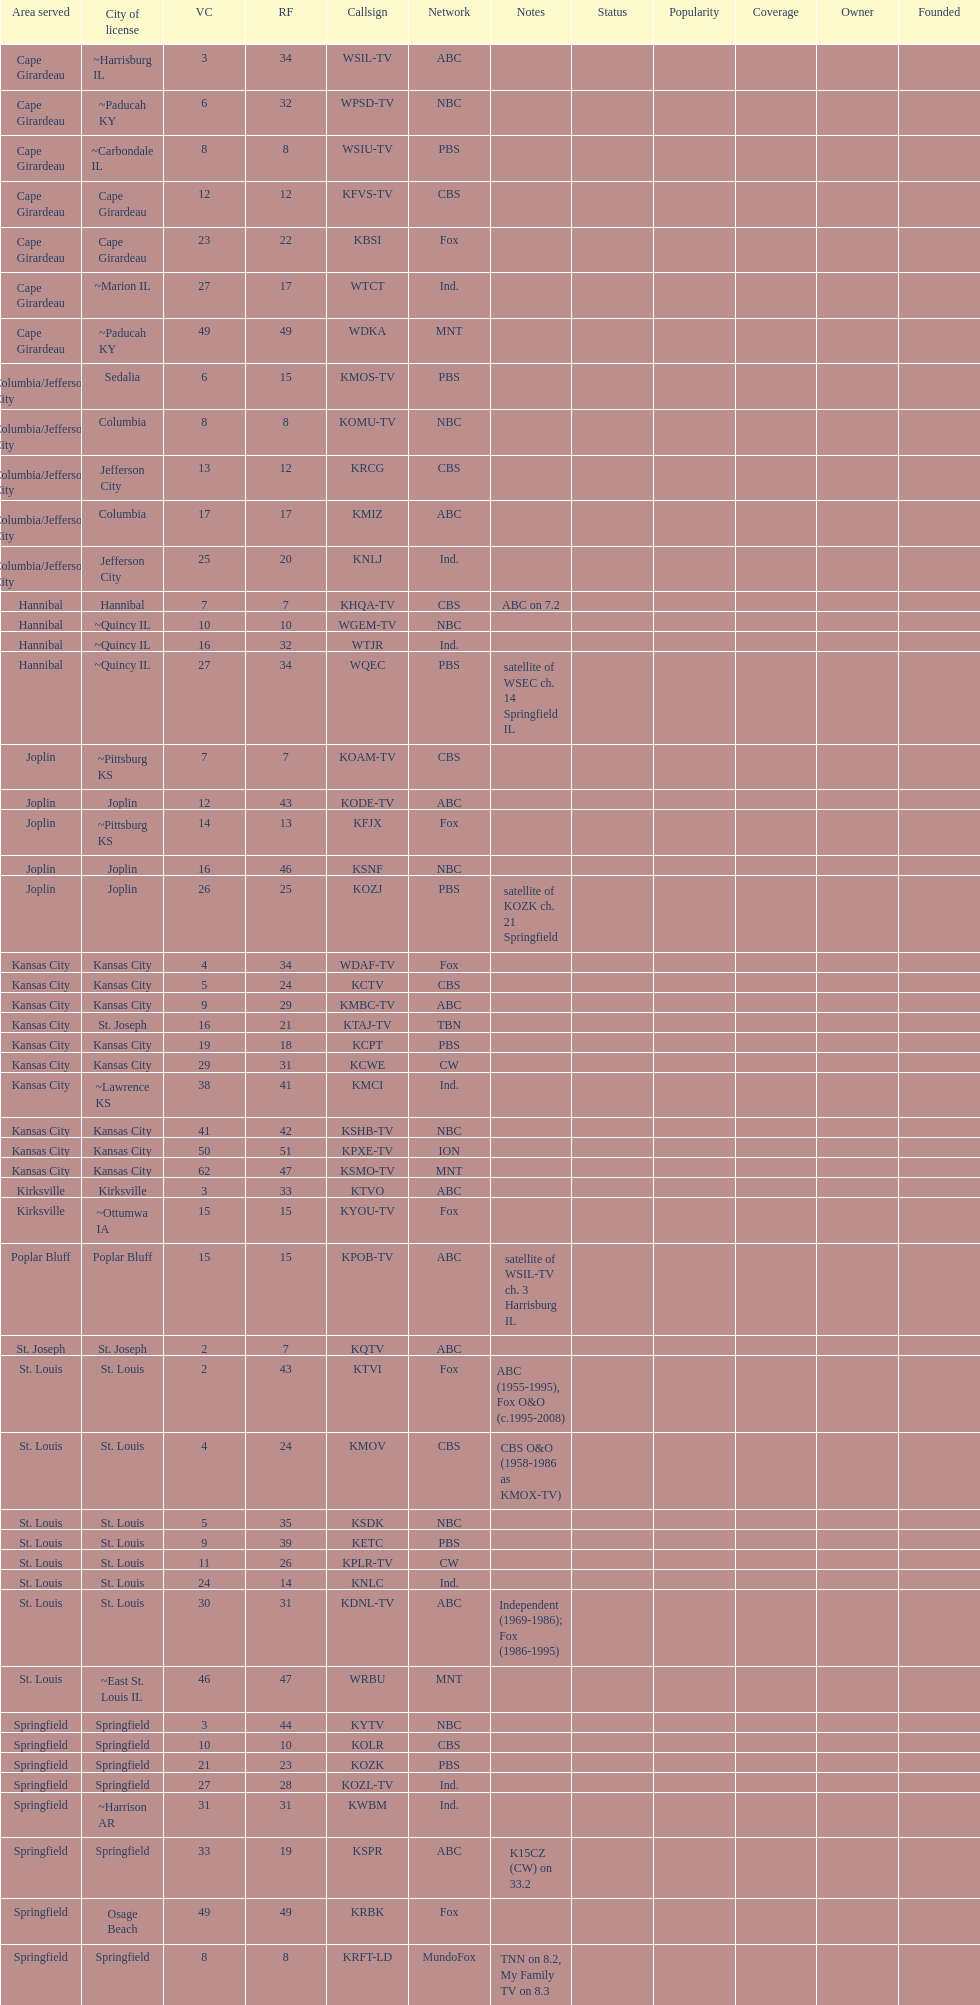Which network includes both kode-tv and wsil-tv as its members? ABC. 